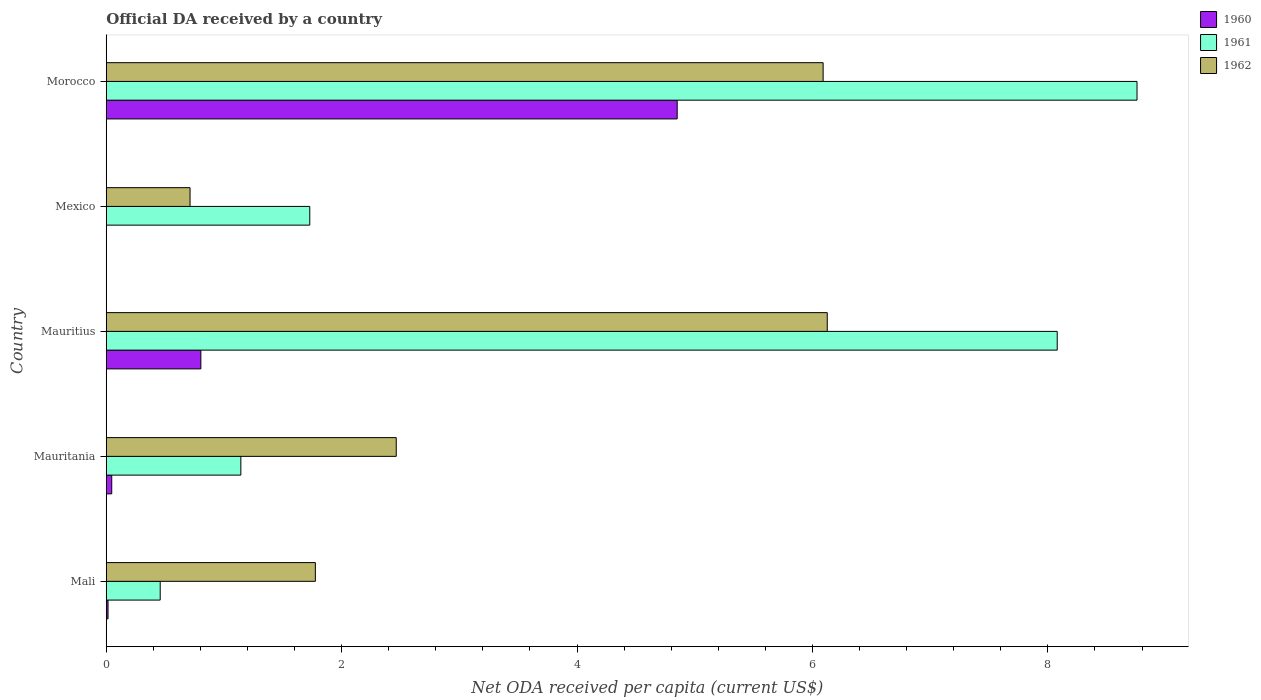How many different coloured bars are there?
Your answer should be compact. 3. How many groups of bars are there?
Give a very brief answer. 5. Are the number of bars on each tick of the Y-axis equal?
Give a very brief answer. No. How many bars are there on the 1st tick from the bottom?
Ensure brevity in your answer.  3. What is the label of the 4th group of bars from the top?
Provide a short and direct response. Mauritania. What is the ODA received in in 1962 in Mauritius?
Your answer should be very brief. 6.13. Across all countries, what is the maximum ODA received in in 1961?
Keep it short and to the point. 8.76. Across all countries, what is the minimum ODA received in in 1960?
Keep it short and to the point. 0. In which country was the ODA received in in 1960 maximum?
Your answer should be compact. Morocco. What is the total ODA received in in 1961 in the graph?
Make the answer very short. 20.17. What is the difference between the ODA received in in 1962 in Mali and that in Morocco?
Keep it short and to the point. -4.31. What is the difference between the ODA received in in 1961 in Mauritius and the ODA received in in 1962 in Morocco?
Your response must be concise. 1.99. What is the average ODA received in in 1961 per country?
Your answer should be compact. 4.03. What is the difference between the ODA received in in 1960 and ODA received in in 1962 in Mali?
Offer a very short reply. -1.76. In how many countries, is the ODA received in in 1961 greater than 5.2 US$?
Your answer should be compact. 2. What is the ratio of the ODA received in in 1961 in Mexico to that in Morocco?
Offer a very short reply. 0.2. Is the difference between the ODA received in in 1960 in Mali and Mauritania greater than the difference between the ODA received in in 1962 in Mali and Mauritania?
Your answer should be compact. Yes. What is the difference between the highest and the second highest ODA received in in 1960?
Provide a short and direct response. 4.05. What is the difference between the highest and the lowest ODA received in in 1960?
Your answer should be compact. 4.85. In how many countries, is the ODA received in in 1961 greater than the average ODA received in in 1961 taken over all countries?
Keep it short and to the point. 2. Is the sum of the ODA received in in 1962 in Mauritius and Morocco greater than the maximum ODA received in in 1961 across all countries?
Give a very brief answer. Yes. Is it the case that in every country, the sum of the ODA received in in 1960 and ODA received in in 1961 is greater than the ODA received in in 1962?
Keep it short and to the point. No. Are all the bars in the graph horizontal?
Your answer should be compact. Yes. Are the values on the major ticks of X-axis written in scientific E-notation?
Give a very brief answer. No. Does the graph contain any zero values?
Keep it short and to the point. Yes. Does the graph contain grids?
Ensure brevity in your answer.  No. Where does the legend appear in the graph?
Provide a succinct answer. Top right. How many legend labels are there?
Give a very brief answer. 3. What is the title of the graph?
Offer a very short reply. Official DA received by a country. What is the label or title of the X-axis?
Offer a very short reply. Net ODA received per capita (current US$). What is the Net ODA received per capita (current US$) of 1960 in Mali?
Ensure brevity in your answer.  0.02. What is the Net ODA received per capita (current US$) of 1961 in Mali?
Offer a very short reply. 0.46. What is the Net ODA received per capita (current US$) in 1962 in Mali?
Give a very brief answer. 1.78. What is the Net ODA received per capita (current US$) of 1960 in Mauritania?
Give a very brief answer. 0.05. What is the Net ODA received per capita (current US$) of 1961 in Mauritania?
Offer a terse response. 1.14. What is the Net ODA received per capita (current US$) in 1962 in Mauritania?
Provide a succinct answer. 2.46. What is the Net ODA received per capita (current US$) in 1960 in Mauritius?
Offer a very short reply. 0.8. What is the Net ODA received per capita (current US$) of 1961 in Mauritius?
Your answer should be compact. 8.08. What is the Net ODA received per capita (current US$) of 1962 in Mauritius?
Give a very brief answer. 6.13. What is the Net ODA received per capita (current US$) of 1960 in Mexico?
Ensure brevity in your answer.  0. What is the Net ODA received per capita (current US$) in 1961 in Mexico?
Provide a short and direct response. 1.73. What is the Net ODA received per capita (current US$) in 1962 in Mexico?
Keep it short and to the point. 0.71. What is the Net ODA received per capita (current US$) of 1960 in Morocco?
Keep it short and to the point. 4.85. What is the Net ODA received per capita (current US$) in 1961 in Morocco?
Your answer should be compact. 8.76. What is the Net ODA received per capita (current US$) of 1962 in Morocco?
Your answer should be compact. 6.09. Across all countries, what is the maximum Net ODA received per capita (current US$) in 1960?
Keep it short and to the point. 4.85. Across all countries, what is the maximum Net ODA received per capita (current US$) in 1961?
Offer a terse response. 8.76. Across all countries, what is the maximum Net ODA received per capita (current US$) of 1962?
Provide a succinct answer. 6.13. Across all countries, what is the minimum Net ODA received per capita (current US$) in 1960?
Your response must be concise. 0. Across all countries, what is the minimum Net ODA received per capita (current US$) of 1961?
Offer a terse response. 0.46. Across all countries, what is the minimum Net ODA received per capita (current US$) of 1962?
Give a very brief answer. 0.71. What is the total Net ODA received per capita (current US$) in 1960 in the graph?
Your answer should be very brief. 5.72. What is the total Net ODA received per capita (current US$) in 1961 in the graph?
Ensure brevity in your answer.  20.17. What is the total Net ODA received per capita (current US$) in 1962 in the graph?
Your answer should be compact. 17.17. What is the difference between the Net ODA received per capita (current US$) of 1960 in Mali and that in Mauritania?
Your answer should be compact. -0.03. What is the difference between the Net ODA received per capita (current US$) in 1961 in Mali and that in Mauritania?
Your answer should be very brief. -0.69. What is the difference between the Net ODA received per capita (current US$) in 1962 in Mali and that in Mauritania?
Make the answer very short. -0.69. What is the difference between the Net ODA received per capita (current US$) of 1960 in Mali and that in Mauritius?
Make the answer very short. -0.79. What is the difference between the Net ODA received per capita (current US$) of 1961 in Mali and that in Mauritius?
Provide a short and direct response. -7.62. What is the difference between the Net ODA received per capita (current US$) of 1962 in Mali and that in Mauritius?
Your response must be concise. -4.35. What is the difference between the Net ODA received per capita (current US$) in 1961 in Mali and that in Mexico?
Offer a terse response. -1.27. What is the difference between the Net ODA received per capita (current US$) of 1962 in Mali and that in Mexico?
Your answer should be very brief. 1.06. What is the difference between the Net ODA received per capita (current US$) of 1960 in Mali and that in Morocco?
Offer a very short reply. -4.84. What is the difference between the Net ODA received per capita (current US$) of 1961 in Mali and that in Morocco?
Offer a terse response. -8.3. What is the difference between the Net ODA received per capita (current US$) in 1962 in Mali and that in Morocco?
Offer a terse response. -4.31. What is the difference between the Net ODA received per capita (current US$) in 1960 in Mauritania and that in Mauritius?
Give a very brief answer. -0.76. What is the difference between the Net ODA received per capita (current US$) of 1961 in Mauritania and that in Mauritius?
Offer a very short reply. -6.94. What is the difference between the Net ODA received per capita (current US$) of 1962 in Mauritania and that in Mauritius?
Ensure brevity in your answer.  -3.66. What is the difference between the Net ODA received per capita (current US$) in 1961 in Mauritania and that in Mexico?
Provide a succinct answer. -0.59. What is the difference between the Net ODA received per capita (current US$) of 1962 in Mauritania and that in Mexico?
Your answer should be very brief. 1.75. What is the difference between the Net ODA received per capita (current US$) of 1960 in Mauritania and that in Morocco?
Give a very brief answer. -4.8. What is the difference between the Net ODA received per capita (current US$) of 1961 in Mauritania and that in Morocco?
Your answer should be compact. -7.61. What is the difference between the Net ODA received per capita (current US$) of 1962 in Mauritania and that in Morocco?
Provide a succinct answer. -3.63. What is the difference between the Net ODA received per capita (current US$) of 1961 in Mauritius and that in Mexico?
Your response must be concise. 6.35. What is the difference between the Net ODA received per capita (current US$) of 1962 in Mauritius and that in Mexico?
Ensure brevity in your answer.  5.41. What is the difference between the Net ODA received per capita (current US$) in 1960 in Mauritius and that in Morocco?
Make the answer very short. -4.05. What is the difference between the Net ODA received per capita (current US$) of 1961 in Mauritius and that in Morocco?
Ensure brevity in your answer.  -0.68. What is the difference between the Net ODA received per capita (current US$) of 1962 in Mauritius and that in Morocco?
Your answer should be compact. 0.04. What is the difference between the Net ODA received per capita (current US$) of 1961 in Mexico and that in Morocco?
Offer a terse response. -7.03. What is the difference between the Net ODA received per capita (current US$) of 1962 in Mexico and that in Morocco?
Keep it short and to the point. -5.38. What is the difference between the Net ODA received per capita (current US$) in 1960 in Mali and the Net ODA received per capita (current US$) in 1961 in Mauritania?
Offer a terse response. -1.13. What is the difference between the Net ODA received per capita (current US$) of 1960 in Mali and the Net ODA received per capita (current US$) of 1962 in Mauritania?
Your answer should be compact. -2.45. What is the difference between the Net ODA received per capita (current US$) in 1961 in Mali and the Net ODA received per capita (current US$) in 1962 in Mauritania?
Provide a succinct answer. -2.01. What is the difference between the Net ODA received per capita (current US$) of 1960 in Mali and the Net ODA received per capita (current US$) of 1961 in Mauritius?
Keep it short and to the point. -8.06. What is the difference between the Net ODA received per capita (current US$) of 1960 in Mali and the Net ODA received per capita (current US$) of 1962 in Mauritius?
Keep it short and to the point. -6.11. What is the difference between the Net ODA received per capita (current US$) in 1961 in Mali and the Net ODA received per capita (current US$) in 1962 in Mauritius?
Give a very brief answer. -5.67. What is the difference between the Net ODA received per capita (current US$) of 1960 in Mali and the Net ODA received per capita (current US$) of 1961 in Mexico?
Offer a very short reply. -1.71. What is the difference between the Net ODA received per capita (current US$) of 1960 in Mali and the Net ODA received per capita (current US$) of 1962 in Mexico?
Provide a succinct answer. -0.7. What is the difference between the Net ODA received per capita (current US$) in 1961 in Mali and the Net ODA received per capita (current US$) in 1962 in Mexico?
Keep it short and to the point. -0.25. What is the difference between the Net ODA received per capita (current US$) in 1960 in Mali and the Net ODA received per capita (current US$) in 1961 in Morocco?
Provide a short and direct response. -8.74. What is the difference between the Net ODA received per capita (current US$) in 1960 in Mali and the Net ODA received per capita (current US$) in 1962 in Morocco?
Keep it short and to the point. -6.08. What is the difference between the Net ODA received per capita (current US$) of 1961 in Mali and the Net ODA received per capita (current US$) of 1962 in Morocco?
Provide a succinct answer. -5.63. What is the difference between the Net ODA received per capita (current US$) in 1960 in Mauritania and the Net ODA received per capita (current US$) in 1961 in Mauritius?
Offer a terse response. -8.03. What is the difference between the Net ODA received per capita (current US$) of 1960 in Mauritania and the Net ODA received per capita (current US$) of 1962 in Mauritius?
Keep it short and to the point. -6.08. What is the difference between the Net ODA received per capita (current US$) in 1961 in Mauritania and the Net ODA received per capita (current US$) in 1962 in Mauritius?
Provide a short and direct response. -4.98. What is the difference between the Net ODA received per capita (current US$) of 1960 in Mauritania and the Net ODA received per capita (current US$) of 1961 in Mexico?
Your answer should be very brief. -1.68. What is the difference between the Net ODA received per capita (current US$) of 1960 in Mauritania and the Net ODA received per capita (current US$) of 1962 in Mexico?
Provide a short and direct response. -0.67. What is the difference between the Net ODA received per capita (current US$) of 1961 in Mauritania and the Net ODA received per capita (current US$) of 1962 in Mexico?
Provide a short and direct response. 0.43. What is the difference between the Net ODA received per capita (current US$) of 1960 in Mauritania and the Net ODA received per capita (current US$) of 1961 in Morocco?
Your answer should be very brief. -8.71. What is the difference between the Net ODA received per capita (current US$) of 1960 in Mauritania and the Net ODA received per capita (current US$) of 1962 in Morocco?
Offer a terse response. -6.04. What is the difference between the Net ODA received per capita (current US$) of 1961 in Mauritania and the Net ODA received per capita (current US$) of 1962 in Morocco?
Offer a very short reply. -4.95. What is the difference between the Net ODA received per capita (current US$) in 1960 in Mauritius and the Net ODA received per capita (current US$) in 1961 in Mexico?
Provide a succinct answer. -0.93. What is the difference between the Net ODA received per capita (current US$) of 1960 in Mauritius and the Net ODA received per capita (current US$) of 1962 in Mexico?
Your answer should be compact. 0.09. What is the difference between the Net ODA received per capita (current US$) in 1961 in Mauritius and the Net ODA received per capita (current US$) in 1962 in Mexico?
Your answer should be compact. 7.37. What is the difference between the Net ODA received per capita (current US$) of 1960 in Mauritius and the Net ODA received per capita (current US$) of 1961 in Morocco?
Offer a very short reply. -7.95. What is the difference between the Net ODA received per capita (current US$) in 1960 in Mauritius and the Net ODA received per capita (current US$) in 1962 in Morocco?
Give a very brief answer. -5.29. What is the difference between the Net ODA received per capita (current US$) in 1961 in Mauritius and the Net ODA received per capita (current US$) in 1962 in Morocco?
Provide a short and direct response. 1.99. What is the difference between the Net ODA received per capita (current US$) of 1961 in Mexico and the Net ODA received per capita (current US$) of 1962 in Morocco?
Make the answer very short. -4.36. What is the average Net ODA received per capita (current US$) of 1960 per country?
Offer a very short reply. 1.14. What is the average Net ODA received per capita (current US$) in 1961 per country?
Make the answer very short. 4.03. What is the average Net ODA received per capita (current US$) of 1962 per country?
Your answer should be compact. 3.43. What is the difference between the Net ODA received per capita (current US$) of 1960 and Net ODA received per capita (current US$) of 1961 in Mali?
Make the answer very short. -0.44. What is the difference between the Net ODA received per capita (current US$) in 1960 and Net ODA received per capita (current US$) in 1962 in Mali?
Offer a very short reply. -1.76. What is the difference between the Net ODA received per capita (current US$) of 1961 and Net ODA received per capita (current US$) of 1962 in Mali?
Provide a short and direct response. -1.32. What is the difference between the Net ODA received per capita (current US$) of 1960 and Net ODA received per capita (current US$) of 1961 in Mauritania?
Your response must be concise. -1.1. What is the difference between the Net ODA received per capita (current US$) of 1960 and Net ODA received per capita (current US$) of 1962 in Mauritania?
Your answer should be compact. -2.42. What is the difference between the Net ODA received per capita (current US$) of 1961 and Net ODA received per capita (current US$) of 1962 in Mauritania?
Offer a very short reply. -1.32. What is the difference between the Net ODA received per capita (current US$) in 1960 and Net ODA received per capita (current US$) in 1961 in Mauritius?
Provide a succinct answer. -7.28. What is the difference between the Net ODA received per capita (current US$) of 1960 and Net ODA received per capita (current US$) of 1962 in Mauritius?
Your answer should be very brief. -5.32. What is the difference between the Net ODA received per capita (current US$) in 1961 and Net ODA received per capita (current US$) in 1962 in Mauritius?
Your answer should be compact. 1.95. What is the difference between the Net ODA received per capita (current US$) of 1961 and Net ODA received per capita (current US$) of 1962 in Mexico?
Your response must be concise. 1.02. What is the difference between the Net ODA received per capita (current US$) of 1960 and Net ODA received per capita (current US$) of 1961 in Morocco?
Your answer should be compact. -3.91. What is the difference between the Net ODA received per capita (current US$) of 1960 and Net ODA received per capita (current US$) of 1962 in Morocco?
Your answer should be very brief. -1.24. What is the difference between the Net ODA received per capita (current US$) in 1961 and Net ODA received per capita (current US$) in 1962 in Morocco?
Offer a terse response. 2.67. What is the ratio of the Net ODA received per capita (current US$) in 1960 in Mali to that in Mauritania?
Keep it short and to the point. 0.33. What is the ratio of the Net ODA received per capita (current US$) in 1961 in Mali to that in Mauritania?
Offer a very short reply. 0.4. What is the ratio of the Net ODA received per capita (current US$) of 1962 in Mali to that in Mauritania?
Your answer should be very brief. 0.72. What is the ratio of the Net ODA received per capita (current US$) in 1960 in Mali to that in Mauritius?
Your answer should be compact. 0.02. What is the ratio of the Net ODA received per capita (current US$) in 1961 in Mali to that in Mauritius?
Offer a terse response. 0.06. What is the ratio of the Net ODA received per capita (current US$) of 1962 in Mali to that in Mauritius?
Your response must be concise. 0.29. What is the ratio of the Net ODA received per capita (current US$) of 1961 in Mali to that in Mexico?
Make the answer very short. 0.27. What is the ratio of the Net ODA received per capita (current US$) in 1962 in Mali to that in Mexico?
Provide a short and direct response. 2.5. What is the ratio of the Net ODA received per capita (current US$) of 1960 in Mali to that in Morocco?
Your response must be concise. 0. What is the ratio of the Net ODA received per capita (current US$) in 1961 in Mali to that in Morocco?
Your response must be concise. 0.05. What is the ratio of the Net ODA received per capita (current US$) of 1962 in Mali to that in Morocco?
Your response must be concise. 0.29. What is the ratio of the Net ODA received per capita (current US$) in 1960 in Mauritania to that in Mauritius?
Offer a very short reply. 0.06. What is the ratio of the Net ODA received per capita (current US$) in 1961 in Mauritania to that in Mauritius?
Your answer should be very brief. 0.14. What is the ratio of the Net ODA received per capita (current US$) in 1962 in Mauritania to that in Mauritius?
Ensure brevity in your answer.  0.4. What is the ratio of the Net ODA received per capita (current US$) of 1961 in Mauritania to that in Mexico?
Your answer should be compact. 0.66. What is the ratio of the Net ODA received per capita (current US$) in 1962 in Mauritania to that in Mexico?
Offer a terse response. 3.46. What is the ratio of the Net ODA received per capita (current US$) in 1960 in Mauritania to that in Morocco?
Keep it short and to the point. 0.01. What is the ratio of the Net ODA received per capita (current US$) of 1961 in Mauritania to that in Morocco?
Keep it short and to the point. 0.13. What is the ratio of the Net ODA received per capita (current US$) of 1962 in Mauritania to that in Morocco?
Make the answer very short. 0.4. What is the ratio of the Net ODA received per capita (current US$) in 1961 in Mauritius to that in Mexico?
Ensure brevity in your answer.  4.67. What is the ratio of the Net ODA received per capita (current US$) of 1962 in Mauritius to that in Mexico?
Make the answer very short. 8.6. What is the ratio of the Net ODA received per capita (current US$) of 1960 in Mauritius to that in Morocco?
Offer a terse response. 0.17. What is the ratio of the Net ODA received per capita (current US$) in 1961 in Mauritius to that in Morocco?
Ensure brevity in your answer.  0.92. What is the ratio of the Net ODA received per capita (current US$) in 1961 in Mexico to that in Morocco?
Keep it short and to the point. 0.2. What is the ratio of the Net ODA received per capita (current US$) of 1962 in Mexico to that in Morocco?
Keep it short and to the point. 0.12. What is the difference between the highest and the second highest Net ODA received per capita (current US$) of 1960?
Ensure brevity in your answer.  4.05. What is the difference between the highest and the second highest Net ODA received per capita (current US$) in 1961?
Your answer should be very brief. 0.68. What is the difference between the highest and the second highest Net ODA received per capita (current US$) in 1962?
Offer a very short reply. 0.04. What is the difference between the highest and the lowest Net ODA received per capita (current US$) of 1960?
Your response must be concise. 4.85. What is the difference between the highest and the lowest Net ODA received per capita (current US$) in 1961?
Offer a very short reply. 8.3. What is the difference between the highest and the lowest Net ODA received per capita (current US$) of 1962?
Provide a short and direct response. 5.41. 